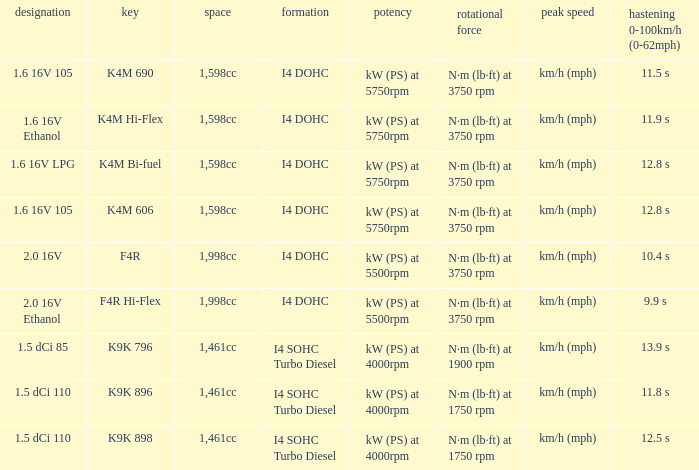What is the code of 1.5 dci 110, which has a capacity of 1,461cc? K9K 896, K9K 898. 